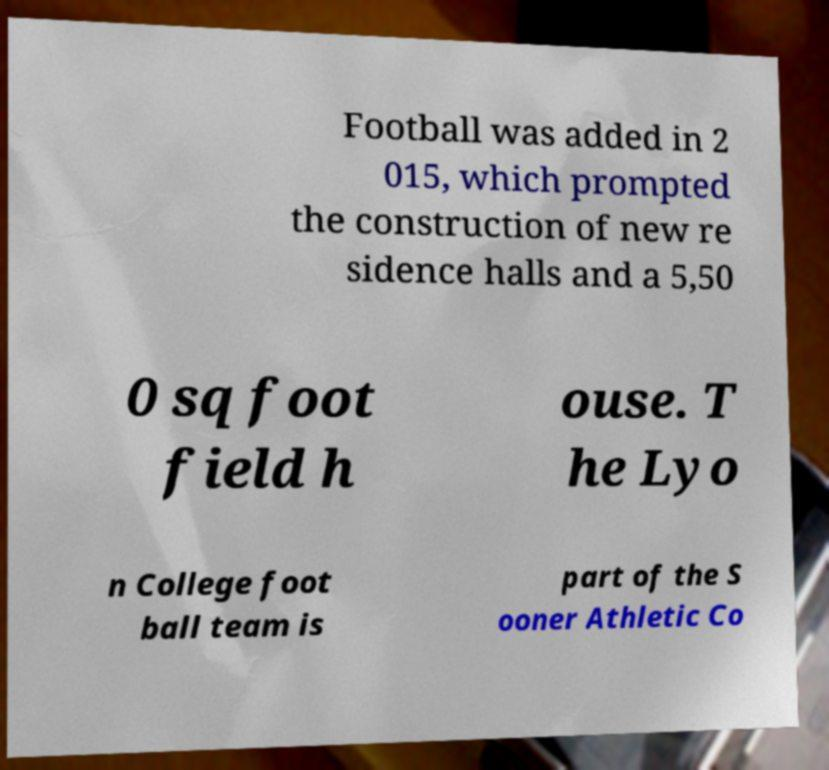Could you extract and type out the text from this image? Football was added in 2 015, which prompted the construction of new re sidence halls and a 5,50 0 sq foot field h ouse. T he Lyo n College foot ball team is part of the S ooner Athletic Co 